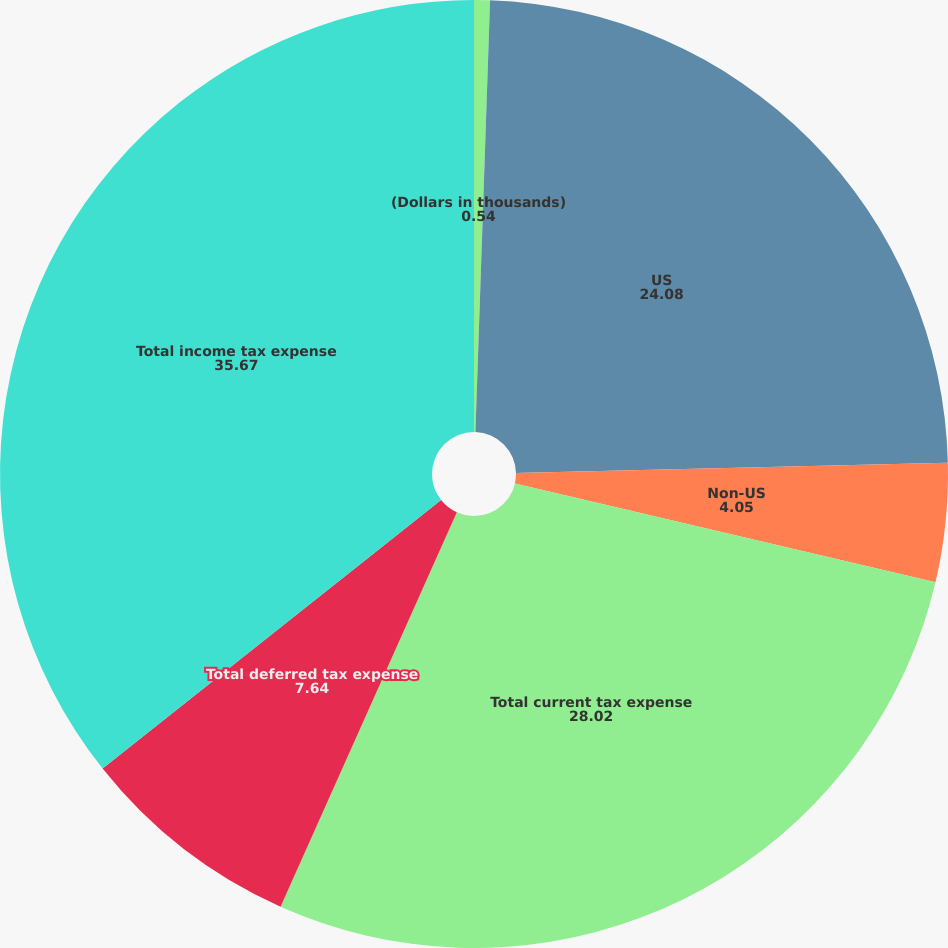<chart> <loc_0><loc_0><loc_500><loc_500><pie_chart><fcel>(Dollars in thousands)<fcel>US<fcel>Non-US<fcel>Total current tax expense<fcel>Total deferred tax expense<fcel>Total income tax expense<nl><fcel>0.54%<fcel>24.08%<fcel>4.05%<fcel>28.02%<fcel>7.64%<fcel>35.67%<nl></chart> 